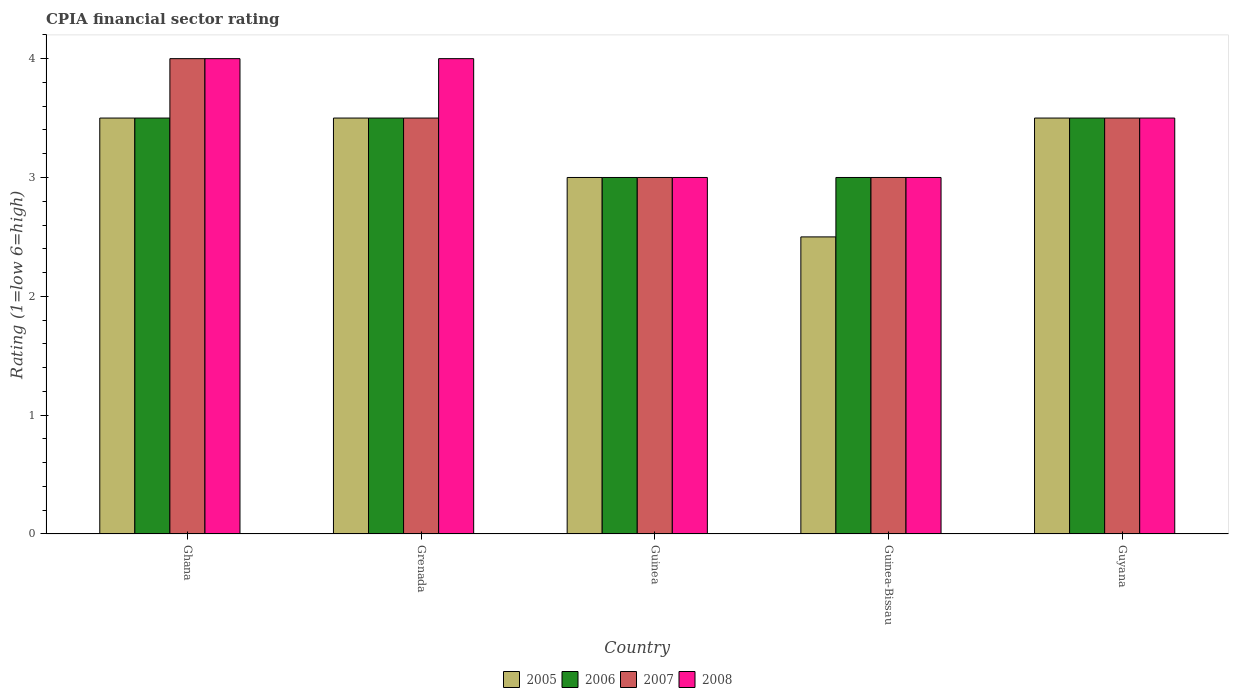How many groups of bars are there?
Your response must be concise. 5. Are the number of bars per tick equal to the number of legend labels?
Offer a terse response. Yes. How many bars are there on the 4th tick from the left?
Provide a succinct answer. 4. What is the label of the 2nd group of bars from the left?
Keep it short and to the point. Grenada. In how many cases, is the number of bars for a given country not equal to the number of legend labels?
Ensure brevity in your answer.  0. Across all countries, what is the minimum CPIA rating in 2006?
Keep it short and to the point. 3. In which country was the CPIA rating in 2007 minimum?
Your response must be concise. Guinea. What is the average CPIA rating in 2008 per country?
Offer a very short reply. 3.5. What is the difference between the highest and the second highest CPIA rating in 2007?
Give a very brief answer. -0.5. What is the difference between the highest and the lowest CPIA rating in 2008?
Keep it short and to the point. 1. Is it the case that in every country, the sum of the CPIA rating in 2005 and CPIA rating in 2006 is greater than the sum of CPIA rating in 2007 and CPIA rating in 2008?
Keep it short and to the point. No. How many countries are there in the graph?
Give a very brief answer. 5. What is the difference between two consecutive major ticks on the Y-axis?
Keep it short and to the point. 1. Are the values on the major ticks of Y-axis written in scientific E-notation?
Keep it short and to the point. No. Does the graph contain grids?
Offer a very short reply. No. How many legend labels are there?
Make the answer very short. 4. What is the title of the graph?
Give a very brief answer. CPIA financial sector rating. Does "1971" appear as one of the legend labels in the graph?
Ensure brevity in your answer.  No. What is the label or title of the Y-axis?
Your answer should be very brief. Rating (1=low 6=high). What is the Rating (1=low 6=high) in 2006 in Ghana?
Give a very brief answer. 3.5. What is the Rating (1=low 6=high) in 2007 in Ghana?
Your response must be concise. 4. What is the Rating (1=low 6=high) in 2005 in Grenada?
Your response must be concise. 3.5. What is the Rating (1=low 6=high) of 2006 in Grenada?
Your response must be concise. 3.5. What is the Rating (1=low 6=high) of 2005 in Guinea?
Your answer should be very brief. 3. What is the Rating (1=low 6=high) in 2006 in Guinea?
Keep it short and to the point. 3. What is the Rating (1=low 6=high) in 2008 in Guinea?
Keep it short and to the point. 3. What is the Rating (1=low 6=high) in 2005 in Guinea-Bissau?
Provide a succinct answer. 2.5. What is the Rating (1=low 6=high) in 2006 in Guinea-Bissau?
Offer a terse response. 3. What is the Rating (1=low 6=high) of 2008 in Guinea-Bissau?
Your response must be concise. 3. What is the Rating (1=low 6=high) in 2005 in Guyana?
Your answer should be very brief. 3.5. What is the Rating (1=low 6=high) in 2007 in Guyana?
Make the answer very short. 3.5. What is the Rating (1=low 6=high) in 2008 in Guyana?
Offer a very short reply. 3.5. Across all countries, what is the maximum Rating (1=low 6=high) in 2006?
Give a very brief answer. 3.5. Across all countries, what is the minimum Rating (1=low 6=high) of 2005?
Keep it short and to the point. 2.5. Across all countries, what is the minimum Rating (1=low 6=high) in 2008?
Offer a very short reply. 3. What is the total Rating (1=low 6=high) of 2006 in the graph?
Ensure brevity in your answer.  16.5. What is the total Rating (1=low 6=high) of 2008 in the graph?
Your answer should be compact. 17.5. What is the difference between the Rating (1=low 6=high) in 2005 in Ghana and that in Grenada?
Provide a succinct answer. 0. What is the difference between the Rating (1=low 6=high) of 2007 in Ghana and that in Guinea?
Your response must be concise. 1. What is the difference between the Rating (1=low 6=high) in 2008 in Ghana and that in Guinea?
Provide a short and direct response. 1. What is the difference between the Rating (1=low 6=high) of 2005 in Ghana and that in Guinea-Bissau?
Give a very brief answer. 1. What is the difference between the Rating (1=low 6=high) in 2005 in Ghana and that in Guyana?
Provide a short and direct response. 0. What is the difference between the Rating (1=low 6=high) of 2006 in Ghana and that in Guyana?
Ensure brevity in your answer.  0. What is the difference between the Rating (1=low 6=high) in 2007 in Ghana and that in Guyana?
Your response must be concise. 0.5. What is the difference between the Rating (1=low 6=high) of 2008 in Ghana and that in Guyana?
Ensure brevity in your answer.  0.5. What is the difference between the Rating (1=low 6=high) in 2006 in Grenada and that in Guinea?
Offer a very short reply. 0.5. What is the difference between the Rating (1=low 6=high) in 2007 in Grenada and that in Guinea?
Make the answer very short. 0.5. What is the difference between the Rating (1=low 6=high) in 2006 in Grenada and that in Guinea-Bissau?
Provide a succinct answer. 0.5. What is the difference between the Rating (1=low 6=high) of 2006 in Grenada and that in Guyana?
Your response must be concise. 0. What is the difference between the Rating (1=low 6=high) of 2005 in Guinea and that in Guinea-Bissau?
Offer a terse response. 0.5. What is the difference between the Rating (1=low 6=high) of 2006 in Guinea and that in Guinea-Bissau?
Offer a very short reply. 0. What is the difference between the Rating (1=low 6=high) in 2007 in Guinea and that in Guinea-Bissau?
Provide a succinct answer. 0. What is the difference between the Rating (1=low 6=high) in 2007 in Guinea and that in Guyana?
Keep it short and to the point. -0.5. What is the difference between the Rating (1=low 6=high) of 2008 in Guinea and that in Guyana?
Keep it short and to the point. -0.5. What is the difference between the Rating (1=low 6=high) in 2006 in Guinea-Bissau and that in Guyana?
Your response must be concise. -0.5. What is the difference between the Rating (1=low 6=high) of 2007 in Guinea-Bissau and that in Guyana?
Give a very brief answer. -0.5. What is the difference between the Rating (1=low 6=high) of 2008 in Guinea-Bissau and that in Guyana?
Offer a terse response. -0.5. What is the difference between the Rating (1=low 6=high) of 2005 in Ghana and the Rating (1=low 6=high) of 2007 in Grenada?
Offer a very short reply. 0. What is the difference between the Rating (1=low 6=high) in 2006 in Ghana and the Rating (1=low 6=high) in 2007 in Grenada?
Keep it short and to the point. 0. What is the difference between the Rating (1=low 6=high) of 2006 in Ghana and the Rating (1=low 6=high) of 2008 in Grenada?
Make the answer very short. -0.5. What is the difference between the Rating (1=low 6=high) in 2005 in Ghana and the Rating (1=low 6=high) in 2006 in Guinea?
Keep it short and to the point. 0.5. What is the difference between the Rating (1=low 6=high) of 2005 in Ghana and the Rating (1=low 6=high) of 2008 in Guinea?
Give a very brief answer. 0.5. What is the difference between the Rating (1=low 6=high) of 2006 in Ghana and the Rating (1=low 6=high) of 2007 in Guinea?
Give a very brief answer. 0.5. What is the difference between the Rating (1=low 6=high) in 2006 in Ghana and the Rating (1=low 6=high) in 2008 in Guinea?
Your answer should be very brief. 0.5. What is the difference between the Rating (1=low 6=high) in 2005 in Ghana and the Rating (1=low 6=high) in 2006 in Guinea-Bissau?
Provide a short and direct response. 0.5. What is the difference between the Rating (1=low 6=high) in 2005 in Ghana and the Rating (1=low 6=high) in 2007 in Guinea-Bissau?
Offer a terse response. 0.5. What is the difference between the Rating (1=low 6=high) in 2005 in Ghana and the Rating (1=low 6=high) in 2008 in Guinea-Bissau?
Offer a terse response. 0.5. What is the difference between the Rating (1=low 6=high) of 2007 in Ghana and the Rating (1=low 6=high) of 2008 in Guinea-Bissau?
Your answer should be compact. 1. What is the difference between the Rating (1=low 6=high) in 2005 in Ghana and the Rating (1=low 6=high) in 2007 in Guyana?
Make the answer very short. 0. What is the difference between the Rating (1=low 6=high) in 2005 in Grenada and the Rating (1=low 6=high) in 2007 in Guinea?
Your answer should be very brief. 0.5. What is the difference between the Rating (1=low 6=high) of 2006 in Grenada and the Rating (1=low 6=high) of 2008 in Guinea?
Ensure brevity in your answer.  0.5. What is the difference between the Rating (1=low 6=high) of 2007 in Grenada and the Rating (1=low 6=high) of 2008 in Guinea?
Give a very brief answer. 0.5. What is the difference between the Rating (1=low 6=high) in 2005 in Grenada and the Rating (1=low 6=high) in 2008 in Guinea-Bissau?
Ensure brevity in your answer.  0.5. What is the difference between the Rating (1=low 6=high) in 2007 in Grenada and the Rating (1=low 6=high) in 2008 in Guinea-Bissau?
Provide a short and direct response. 0.5. What is the difference between the Rating (1=low 6=high) in 2005 in Grenada and the Rating (1=low 6=high) in 2006 in Guyana?
Your answer should be compact. 0. What is the difference between the Rating (1=low 6=high) in 2005 in Grenada and the Rating (1=low 6=high) in 2008 in Guyana?
Offer a terse response. 0. What is the difference between the Rating (1=low 6=high) in 2006 in Grenada and the Rating (1=low 6=high) in 2007 in Guyana?
Offer a terse response. 0. What is the difference between the Rating (1=low 6=high) in 2005 in Guinea and the Rating (1=low 6=high) in 2008 in Guinea-Bissau?
Your answer should be very brief. 0. What is the difference between the Rating (1=low 6=high) in 2006 in Guinea and the Rating (1=low 6=high) in 2007 in Guinea-Bissau?
Offer a very short reply. 0. What is the difference between the Rating (1=low 6=high) of 2005 in Guinea and the Rating (1=low 6=high) of 2006 in Guyana?
Your response must be concise. -0.5. What is the difference between the Rating (1=low 6=high) in 2005 in Guinea and the Rating (1=low 6=high) in 2008 in Guyana?
Your answer should be very brief. -0.5. What is the difference between the Rating (1=low 6=high) of 2006 in Guinea and the Rating (1=low 6=high) of 2007 in Guyana?
Ensure brevity in your answer.  -0.5. What is the difference between the Rating (1=low 6=high) in 2005 in Guinea-Bissau and the Rating (1=low 6=high) in 2006 in Guyana?
Ensure brevity in your answer.  -1. What is the difference between the Rating (1=low 6=high) of 2005 in Guinea-Bissau and the Rating (1=low 6=high) of 2007 in Guyana?
Your answer should be very brief. -1. What is the difference between the Rating (1=low 6=high) in 2005 in Guinea-Bissau and the Rating (1=low 6=high) in 2008 in Guyana?
Provide a short and direct response. -1. What is the difference between the Rating (1=low 6=high) of 2006 in Guinea-Bissau and the Rating (1=low 6=high) of 2007 in Guyana?
Your response must be concise. -0.5. What is the average Rating (1=low 6=high) in 2006 per country?
Offer a terse response. 3.3. What is the average Rating (1=low 6=high) of 2008 per country?
Your answer should be very brief. 3.5. What is the difference between the Rating (1=low 6=high) in 2005 and Rating (1=low 6=high) in 2007 in Ghana?
Provide a short and direct response. -0.5. What is the difference between the Rating (1=low 6=high) in 2005 and Rating (1=low 6=high) in 2008 in Ghana?
Your answer should be compact. -0.5. What is the difference between the Rating (1=low 6=high) of 2006 and Rating (1=low 6=high) of 2008 in Ghana?
Your response must be concise. -0.5. What is the difference between the Rating (1=low 6=high) of 2007 and Rating (1=low 6=high) of 2008 in Ghana?
Give a very brief answer. 0. What is the difference between the Rating (1=low 6=high) in 2005 and Rating (1=low 6=high) in 2006 in Grenada?
Your answer should be very brief. 0. What is the difference between the Rating (1=low 6=high) of 2006 and Rating (1=low 6=high) of 2007 in Grenada?
Your response must be concise. 0. What is the difference between the Rating (1=low 6=high) in 2005 and Rating (1=low 6=high) in 2006 in Guinea?
Make the answer very short. 0. What is the difference between the Rating (1=low 6=high) in 2005 and Rating (1=low 6=high) in 2007 in Guinea?
Provide a short and direct response. 0. What is the difference between the Rating (1=low 6=high) of 2006 and Rating (1=low 6=high) of 2008 in Guinea?
Offer a terse response. 0. What is the difference between the Rating (1=low 6=high) in 2005 and Rating (1=low 6=high) in 2006 in Guinea-Bissau?
Keep it short and to the point. -0.5. What is the difference between the Rating (1=low 6=high) of 2005 and Rating (1=low 6=high) of 2008 in Guinea-Bissau?
Your answer should be compact. -0.5. What is the difference between the Rating (1=low 6=high) of 2006 and Rating (1=low 6=high) of 2007 in Guinea-Bissau?
Offer a terse response. 0. What is the difference between the Rating (1=low 6=high) in 2006 and Rating (1=low 6=high) in 2008 in Guinea-Bissau?
Your response must be concise. 0. What is the difference between the Rating (1=low 6=high) of 2007 and Rating (1=low 6=high) of 2008 in Guinea-Bissau?
Provide a short and direct response. 0. What is the difference between the Rating (1=low 6=high) of 2005 and Rating (1=low 6=high) of 2006 in Guyana?
Give a very brief answer. 0. What is the difference between the Rating (1=low 6=high) of 2005 and Rating (1=low 6=high) of 2007 in Guyana?
Make the answer very short. 0. What is the difference between the Rating (1=low 6=high) of 2006 and Rating (1=low 6=high) of 2008 in Guyana?
Your answer should be very brief. 0. What is the difference between the Rating (1=low 6=high) of 2007 and Rating (1=low 6=high) of 2008 in Guyana?
Keep it short and to the point. 0. What is the ratio of the Rating (1=low 6=high) in 2006 in Ghana to that in Grenada?
Your answer should be very brief. 1. What is the ratio of the Rating (1=low 6=high) in 2007 in Ghana to that in Grenada?
Your answer should be compact. 1.14. What is the ratio of the Rating (1=low 6=high) in 2005 in Ghana to that in Guinea?
Provide a succinct answer. 1.17. What is the ratio of the Rating (1=low 6=high) in 2008 in Ghana to that in Guinea?
Offer a terse response. 1.33. What is the ratio of the Rating (1=low 6=high) of 2005 in Ghana to that in Guinea-Bissau?
Provide a short and direct response. 1.4. What is the ratio of the Rating (1=low 6=high) in 2006 in Ghana to that in Guyana?
Keep it short and to the point. 1. What is the ratio of the Rating (1=low 6=high) of 2007 in Ghana to that in Guyana?
Offer a very short reply. 1.14. What is the ratio of the Rating (1=low 6=high) of 2006 in Grenada to that in Guinea?
Give a very brief answer. 1.17. What is the ratio of the Rating (1=low 6=high) in 2008 in Grenada to that in Guinea?
Your answer should be very brief. 1.33. What is the ratio of the Rating (1=low 6=high) of 2007 in Grenada to that in Guinea-Bissau?
Offer a very short reply. 1.17. What is the ratio of the Rating (1=low 6=high) of 2008 in Grenada to that in Guinea-Bissau?
Provide a succinct answer. 1.33. What is the ratio of the Rating (1=low 6=high) in 2006 in Grenada to that in Guyana?
Make the answer very short. 1. What is the ratio of the Rating (1=low 6=high) in 2007 in Grenada to that in Guyana?
Your response must be concise. 1. What is the ratio of the Rating (1=low 6=high) of 2005 in Guinea to that in Guinea-Bissau?
Provide a succinct answer. 1.2. What is the ratio of the Rating (1=low 6=high) in 2006 in Guinea to that in Guinea-Bissau?
Provide a short and direct response. 1. What is the ratio of the Rating (1=low 6=high) of 2005 in Guinea to that in Guyana?
Keep it short and to the point. 0.86. What is the ratio of the Rating (1=low 6=high) of 2007 in Guinea to that in Guyana?
Give a very brief answer. 0.86. What is the ratio of the Rating (1=low 6=high) in 2005 in Guinea-Bissau to that in Guyana?
Make the answer very short. 0.71. What is the ratio of the Rating (1=low 6=high) in 2008 in Guinea-Bissau to that in Guyana?
Give a very brief answer. 0.86. What is the difference between the highest and the second highest Rating (1=low 6=high) in 2006?
Keep it short and to the point. 0. What is the difference between the highest and the second highest Rating (1=low 6=high) of 2008?
Your answer should be compact. 0. What is the difference between the highest and the lowest Rating (1=low 6=high) of 2008?
Offer a very short reply. 1. 